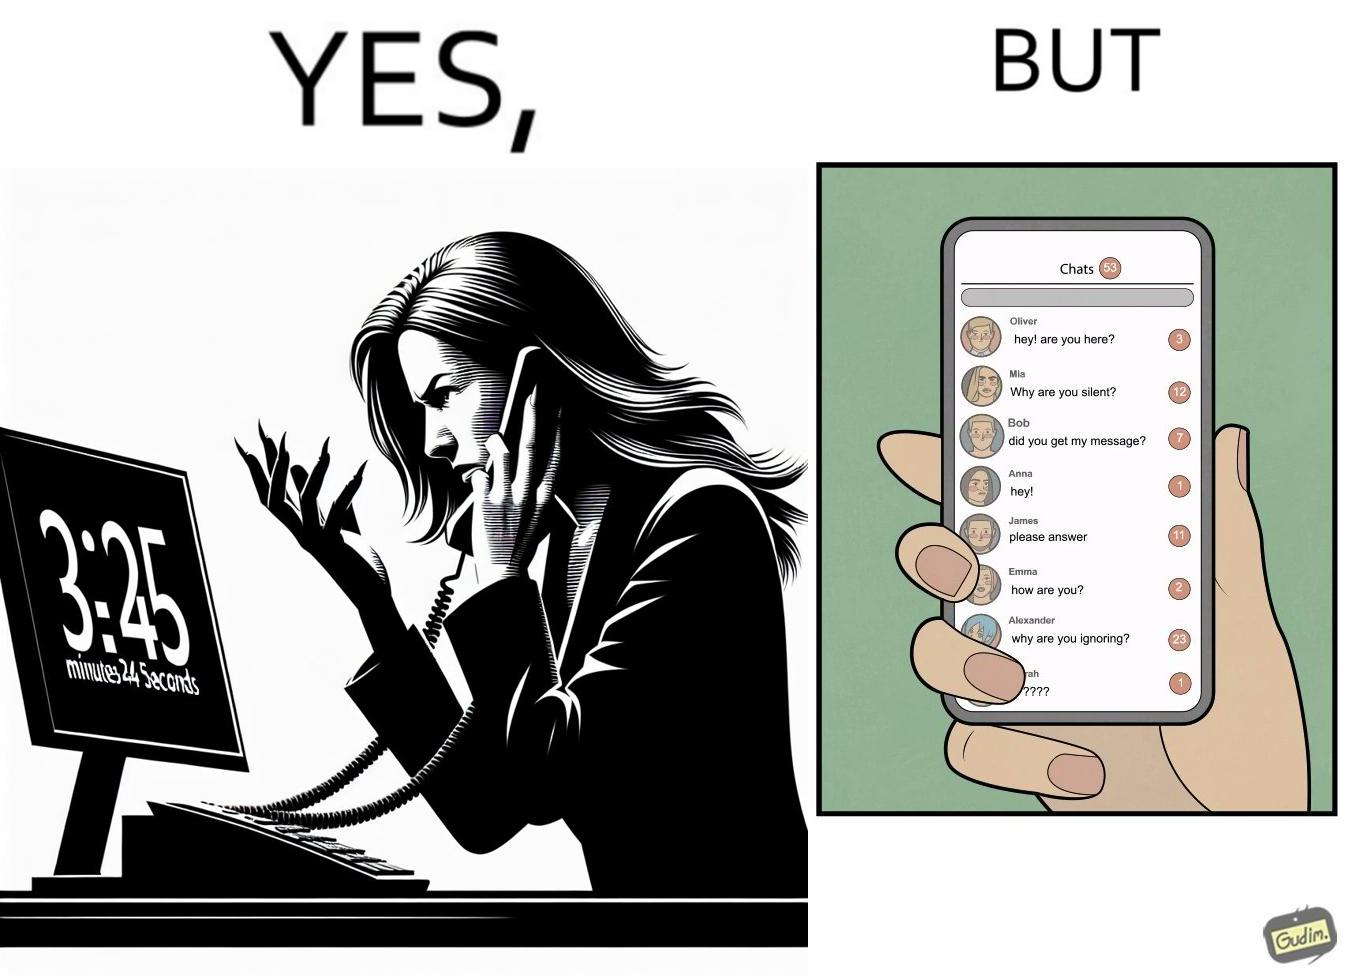What do you see in each half of this image? In the left part of the image: The image shows an annoyed woman talking to the representative in the call center on her mobile phone for over 23 minutes and 45 seconds. In the right part of the image: The image shows the chats of a person on their phone. There are a total of 53 unread chats. In the unanswered chats, the people on the other end are asking if this person got their message or if this person is ignoring them. 